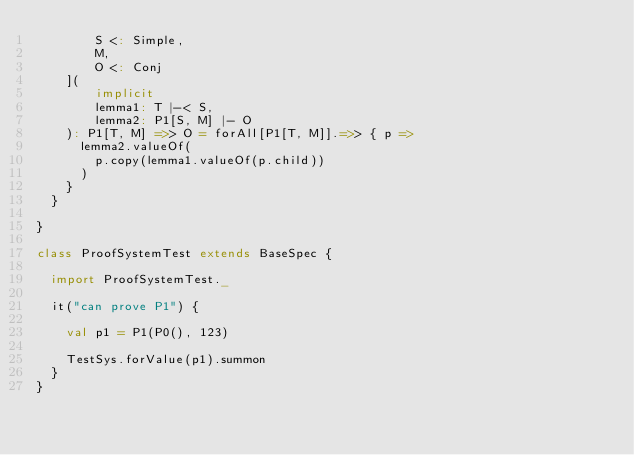<code> <loc_0><loc_0><loc_500><loc_500><_Scala_>        S <: Simple,
        M,
        O <: Conj
    ](
        implicit
        lemma1: T |-< S,
        lemma2: P1[S, M] |- O
    ): P1[T, M] =>> O = forAll[P1[T, M]].=>> { p =>
      lemma2.valueOf(
        p.copy(lemma1.valueOf(p.child))
      )
    }
  }

}

class ProofSystemTest extends BaseSpec {

  import ProofSystemTest._

  it("can prove P1") {

    val p1 = P1(P0(), 123)

    TestSys.forValue(p1).summon
  }
}
</code> 